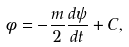<formula> <loc_0><loc_0><loc_500><loc_500>\phi = - \frac { m } { 2 } \frac { d \psi } { d t } + C ,</formula> 